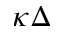Convert formula to latex. <formula><loc_0><loc_0><loc_500><loc_500>\kappa \Delta</formula> 